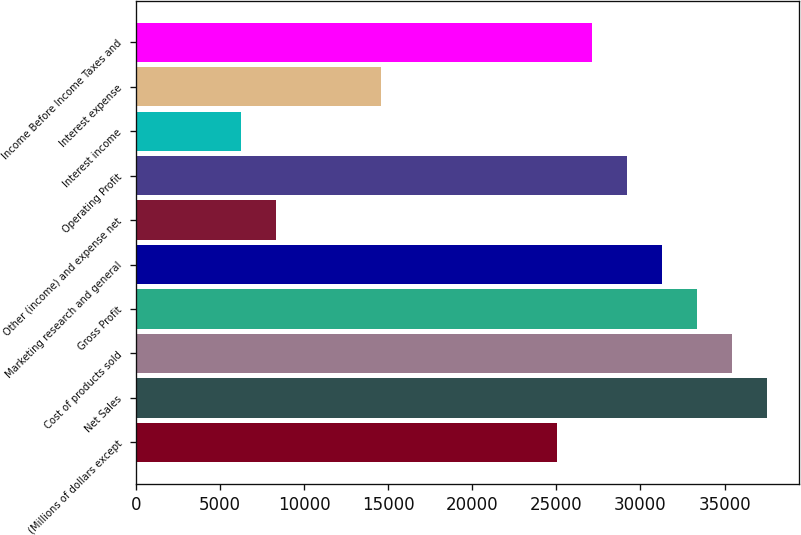Convert chart. <chart><loc_0><loc_0><loc_500><loc_500><bar_chart><fcel>(Millions of dollars except<fcel>Net Sales<fcel>Cost of products sold<fcel>Gross Profit<fcel>Marketing research and general<fcel>Other (income) and expense net<fcel>Operating Profit<fcel>Interest income<fcel>Interest expense<fcel>Income Before Income Taxes and<nl><fcel>25014.6<fcel>37520.6<fcel>35436.2<fcel>33351.9<fcel>31267.6<fcel>8340.08<fcel>29183.3<fcel>6255.76<fcel>14593<fcel>27099<nl></chart> 